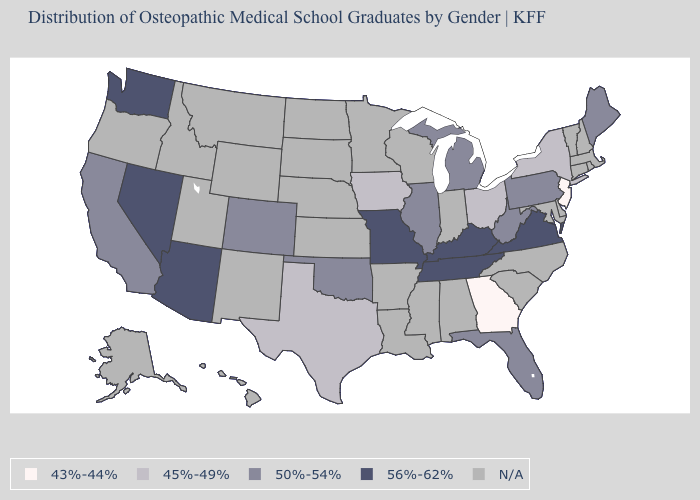Which states have the lowest value in the West?
Be succinct. California, Colorado. What is the value of Colorado?
Concise answer only. 50%-54%. What is the value of Alabama?
Give a very brief answer. N/A. How many symbols are there in the legend?
Concise answer only. 5. Does New Jersey have the lowest value in the USA?
Be succinct. Yes. Name the states that have a value in the range 45%-49%?
Concise answer only. Iowa, New York, Ohio, Texas. Among the states that border Alabama , which have the highest value?
Answer briefly. Tennessee. What is the value of Wyoming?
Give a very brief answer. N/A. What is the highest value in the Northeast ?
Answer briefly. 50%-54%. What is the value of New York?
Quick response, please. 45%-49%. 